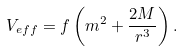<formula> <loc_0><loc_0><loc_500><loc_500>V _ { e f f } = f \left ( m ^ { 2 } + \frac { 2 M } { r ^ { 3 } } \right ) .</formula> 